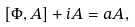Convert formula to latex. <formula><loc_0><loc_0><loc_500><loc_500>[ \Phi , A ] + i A = a A ,</formula> 